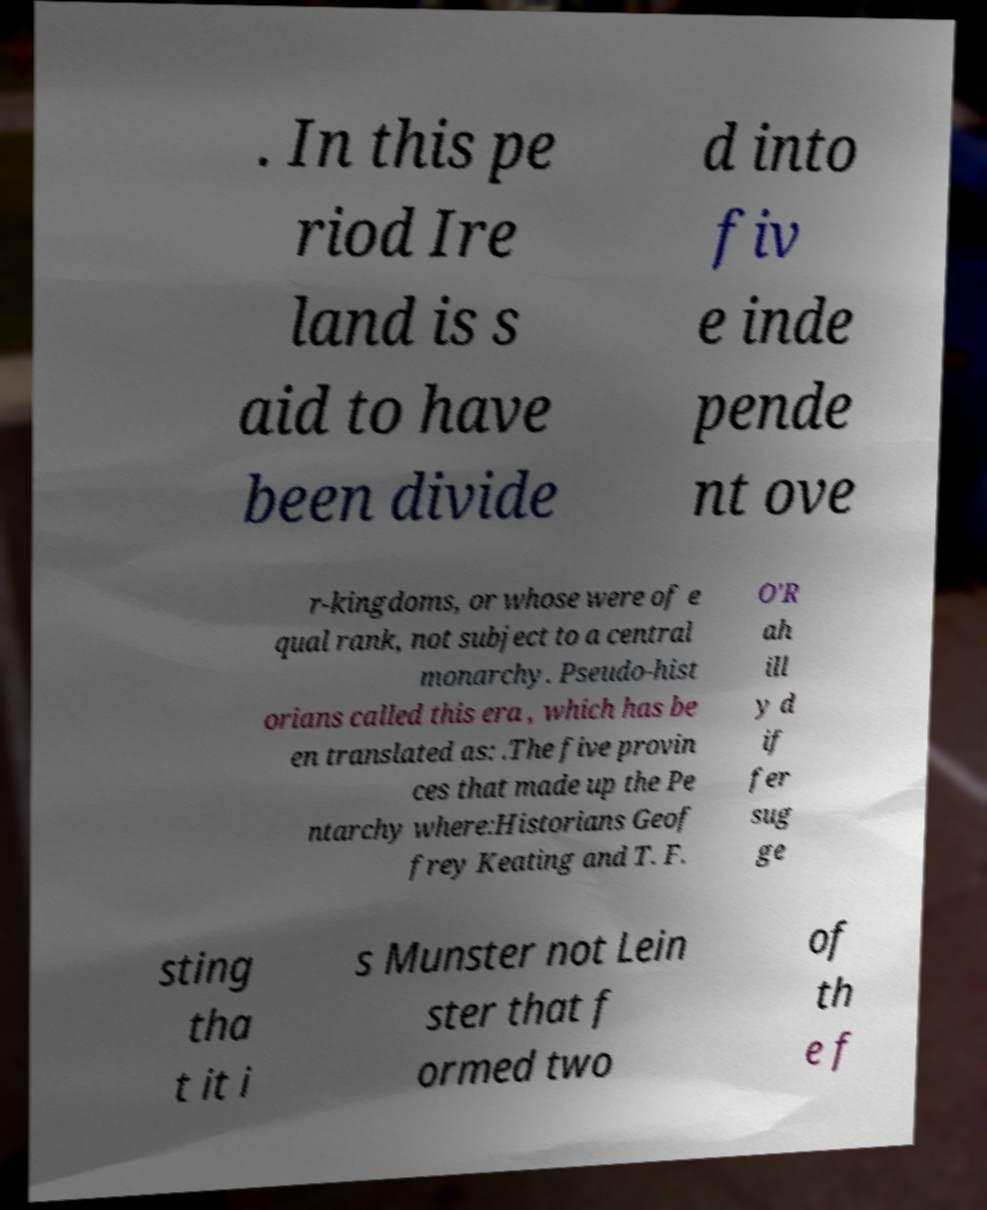Could you assist in decoding the text presented in this image and type it out clearly? . In this pe riod Ire land is s aid to have been divide d into fiv e inde pende nt ove r-kingdoms, or whose were of e qual rank, not subject to a central monarchy. Pseudo-hist orians called this era , which has be en translated as: .The five provin ces that made up the Pe ntarchy where:Historians Geof frey Keating and T. F. O'R ah ill y d if fer sug ge sting tha t it i s Munster not Lein ster that f ormed two of th e f 